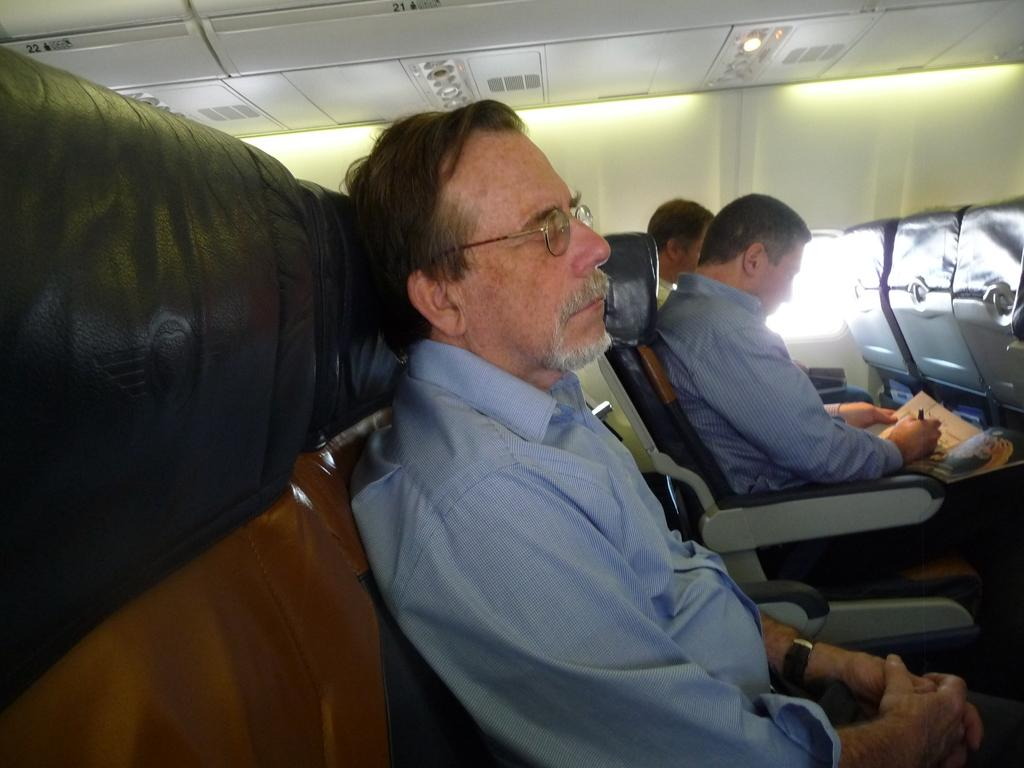How many people are in the image? There are three people in the image. What are the people doing in the image? The people are sitting in seats. Where was the image taken? The image was taken inside a vehicle. What type of goldfish can be seen swimming in the image? There are no goldfish present in the image; it features three people sitting in seats inside a vehicle. 